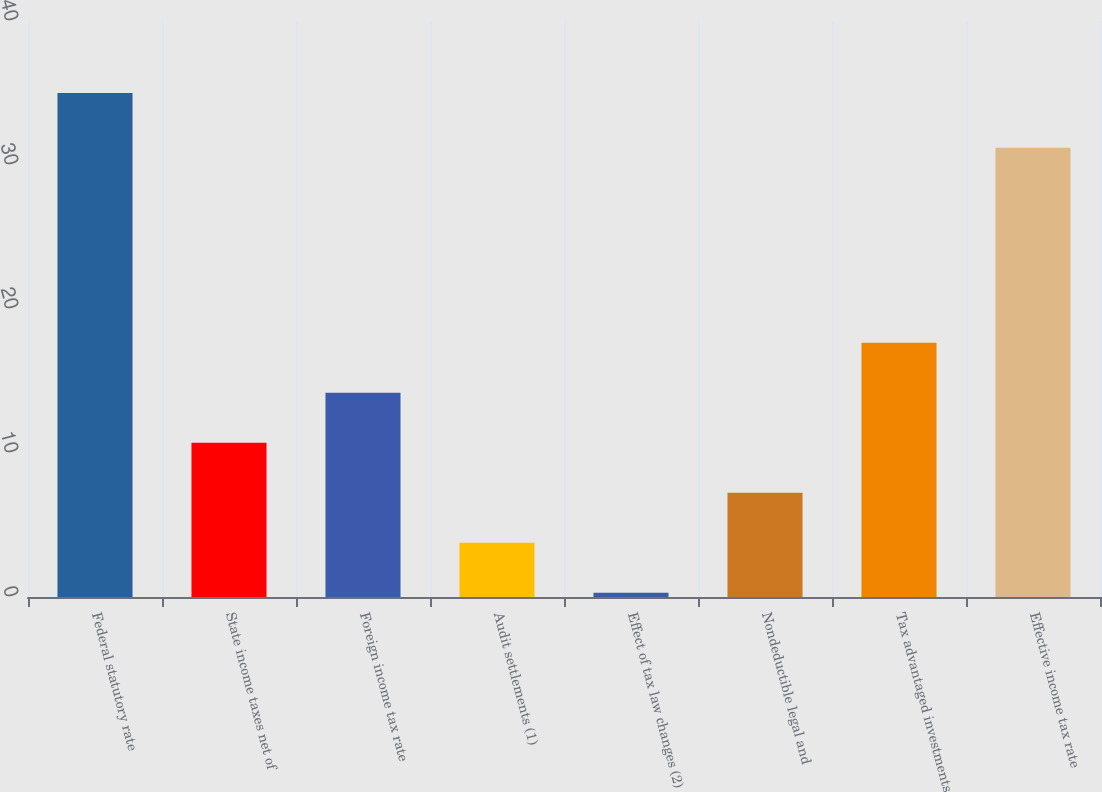Convert chart. <chart><loc_0><loc_0><loc_500><loc_500><bar_chart><fcel>Federal statutory rate<fcel>State income taxes net of<fcel>Foreign income tax rate<fcel>Audit settlements (1)<fcel>Effect of tax law changes (2)<fcel>Nondeductible legal and<fcel>Tax advantaged investments<fcel>Effective income tax rate<nl><fcel>35<fcel>10.71<fcel>14.18<fcel>3.77<fcel>0.3<fcel>7.24<fcel>17.65<fcel>31.2<nl></chart> 